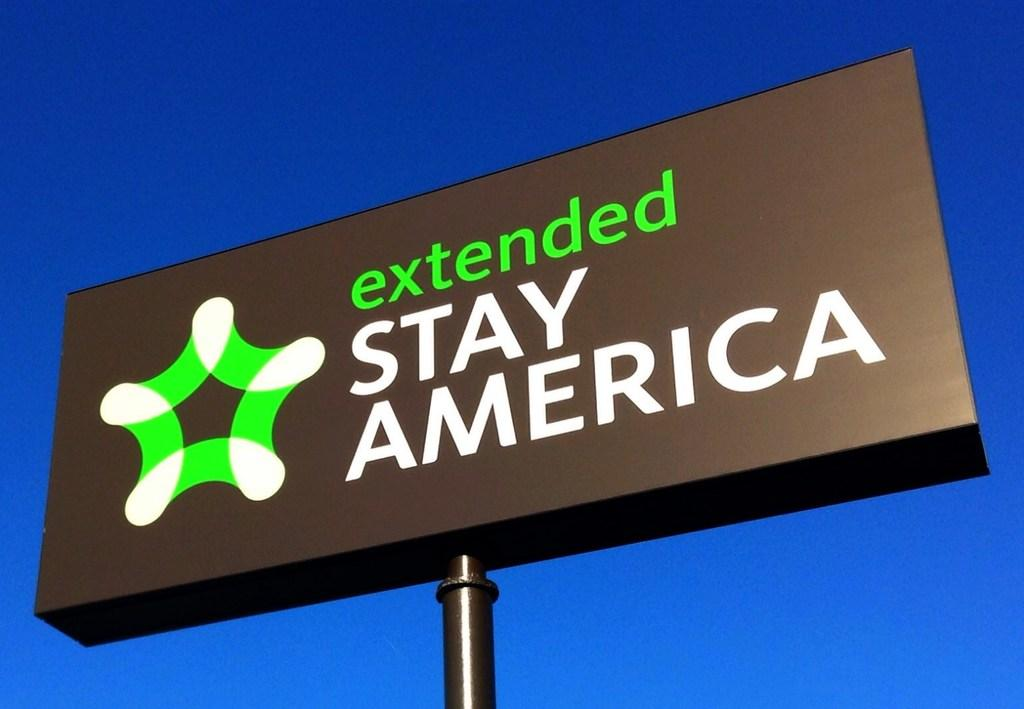<image>
Relay a brief, clear account of the picture shown. a billboard that says 'extended stay america' on it 